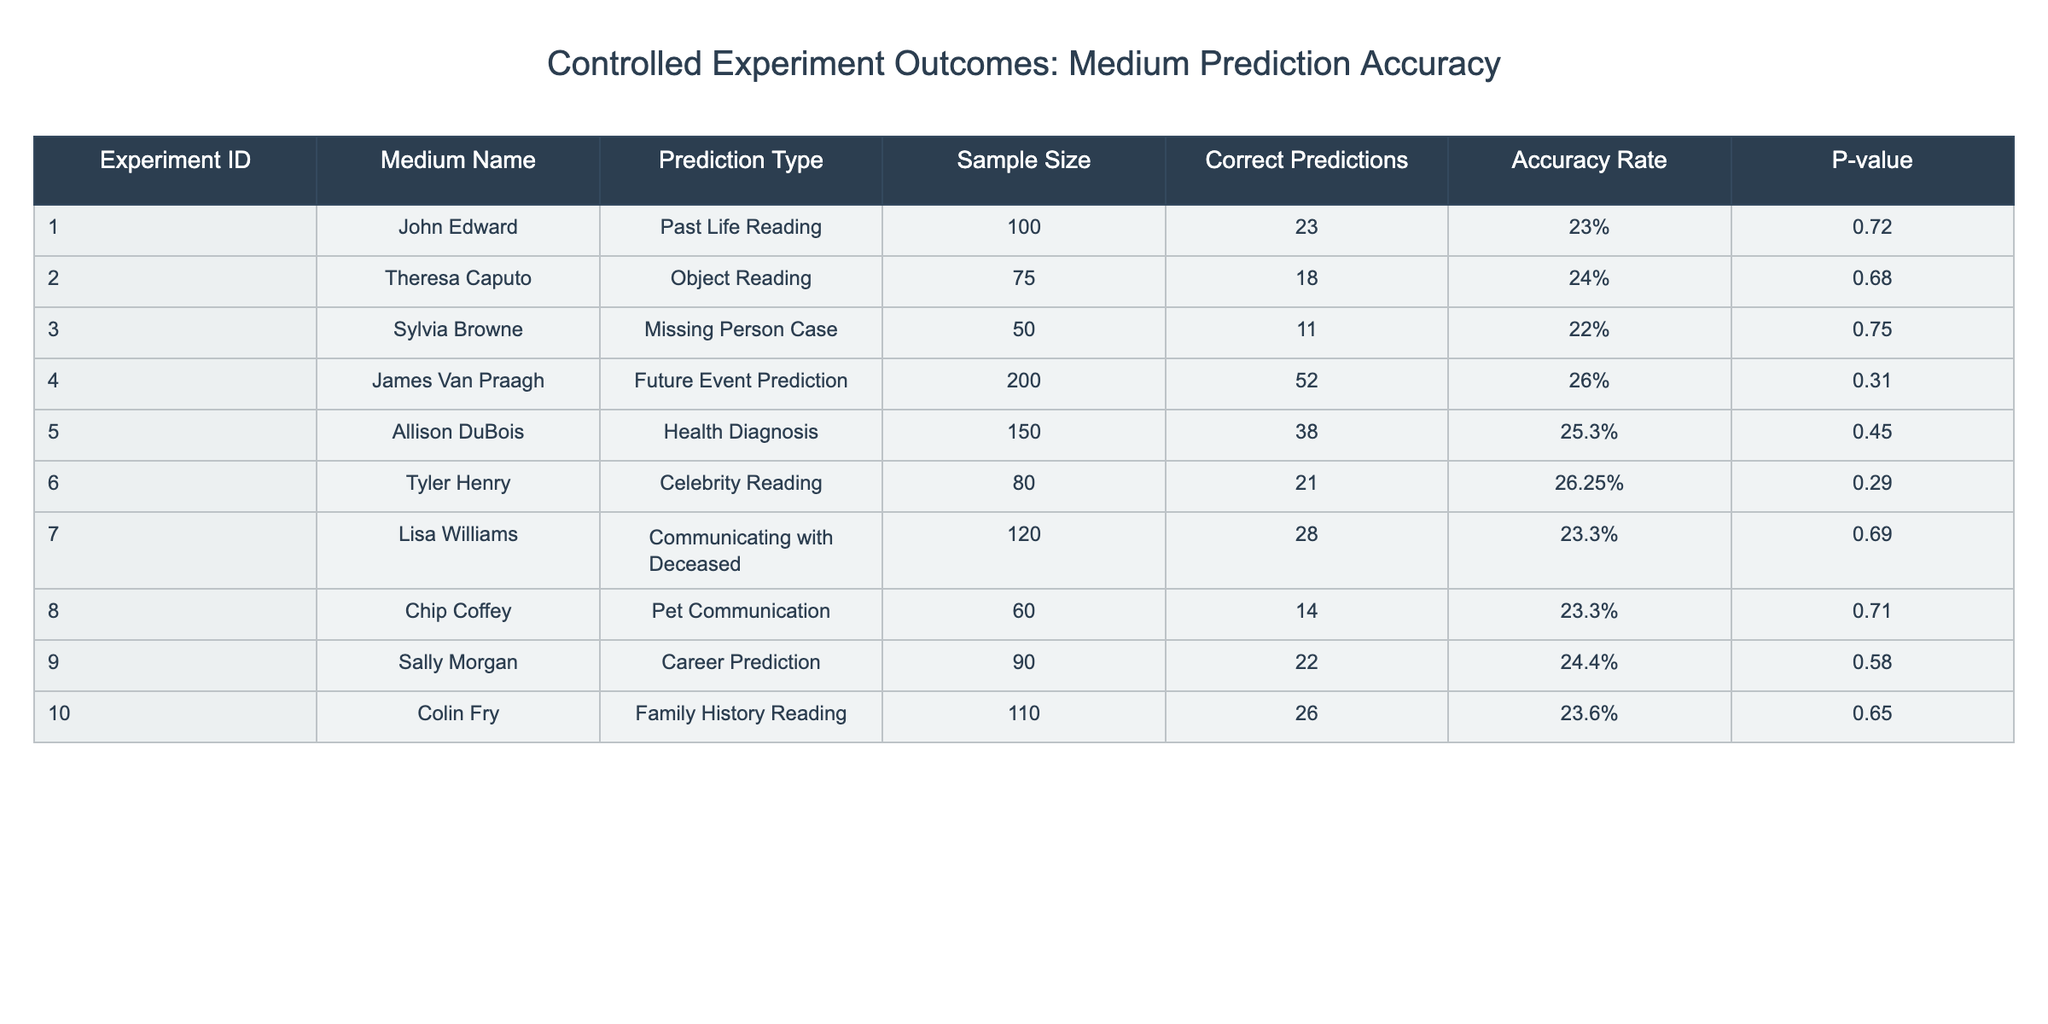What is the highest accuracy rate among the mediums listed? The table shows the accuracy rates for each medium. I will look through the accuracy rates (23%, 24%, 22%, 26%, 25.3%, 26.25%, 23.3%, 23.3%, 24.4%, 23.6%). The highest value is 26.25%, associated with Tyler Henry.
Answer: 26.25% Which medium had the lowest number of correct predictions? From the table, I check the "Correct Predictions" column and find the values (23, 18, 11, 52, 38, 21, 28, 14, 22, 26). The lowest number of correct predictions is 11 from Sylvia Browne.
Answer: 11 What is the combined sample size of all the experiments? To find the combined sample size, I add the values in the "Sample Size" column (100 + 75 + 50 + 200 + 150 + 80 + 120 + 60 + 90 + 110). The total equals 1,015.
Answer: 1,015 Did any medium have an accuracy rate of 30% or higher? I need to check the "Accuracy Rate" column for values 30% or greater. The highest listed accuracy is 26.25%, so no mediums meet this criterion.
Answer: No What is the average correct prediction rate across all mediums? I will first sum the correct predictions (23 + 18 + 11 + 52 + 38 + 21 + 28 + 14 + 22 + 26 =  329) and divide by the total number of mediums (10). This gives me an average of 32.9.
Answer: 32.9 Which medium had the highest p-value, indicating the least statistical significance in their predictions? I will check the "P-value" column (0.72, 0.68, 0.75, 0.31, 0.45, 0.29, 0.69, 0.71, 0.58, 0.65) for the maximum value. The highest is 0.75 from Sylvia Browne.
Answer: 0.75 How many mediums had an accuracy rate below 25%? I will review each medium's accuracy rates and count those that fall below 25% (23%, 24%, 22%, 23.3%, 23.3%, 23.6%). There are 6 instances.
Answer: 6 If we eliminate the top two mediums based on accuracy, what is the new average accuracy rate? First, identify the highest two accuracy rates (26.25% and 26%). Removing them leaves rates (23%, 24%, 22%, 25.3%, 23.3%, 23.3%, 24.4%, 23.6%). Summing these (23 + 24 + 22 + 25.3 + 23.3 + 23.3 + 24.4 + 23.6 =  194.2) and dividing by 8 gives an average of 24.275%.
Answer: 24.28% Which prediction type had the greatest number of participants? I will look at the "Sample Size" column and determine the largest entry (200 in the Future Event Prediction).
Answer: 200 How many mediums had p-values less than 0.5? By examining the list of p-values (0.72, 0.68, 0.75, 0.31, 0.45, 0.29, 0.69, 0.71, 0.58, 0.65), I find those under 0.5 are 0.31, 0.45, and 0.29, making it 3 mediums.
Answer: 3 